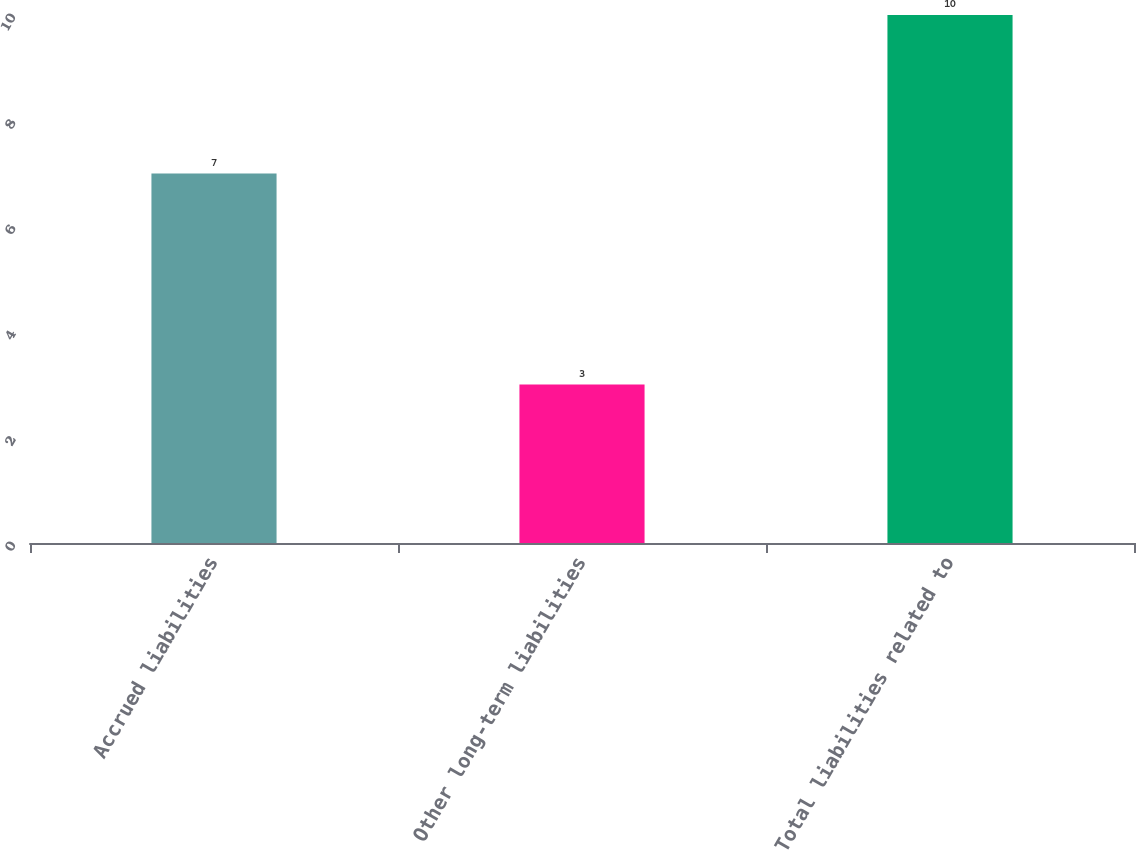<chart> <loc_0><loc_0><loc_500><loc_500><bar_chart><fcel>Accrued liabilities<fcel>Other long-term liabilities<fcel>Total liabilities related to<nl><fcel>7<fcel>3<fcel>10<nl></chart> 